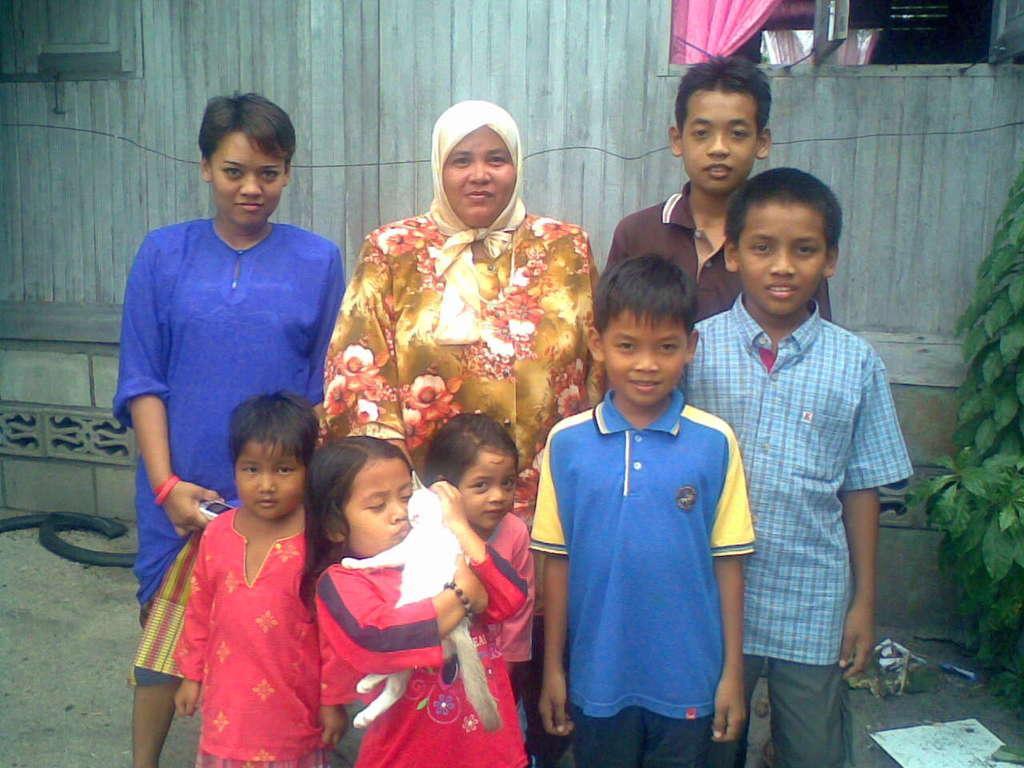Can you describe this image briefly? In the middle of the image few people are standing and smiling. Behind them there is wall. On the right side of the image there is a plant and this girl holding a cat. 